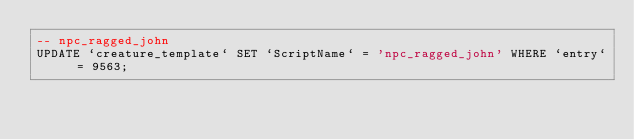Convert code to text. <code><loc_0><loc_0><loc_500><loc_500><_SQL_>-- npc_ragged_john
UPDATE `creature_template` SET `ScriptName` = 'npc_ragged_john' WHERE `entry` = 9563;
</code> 